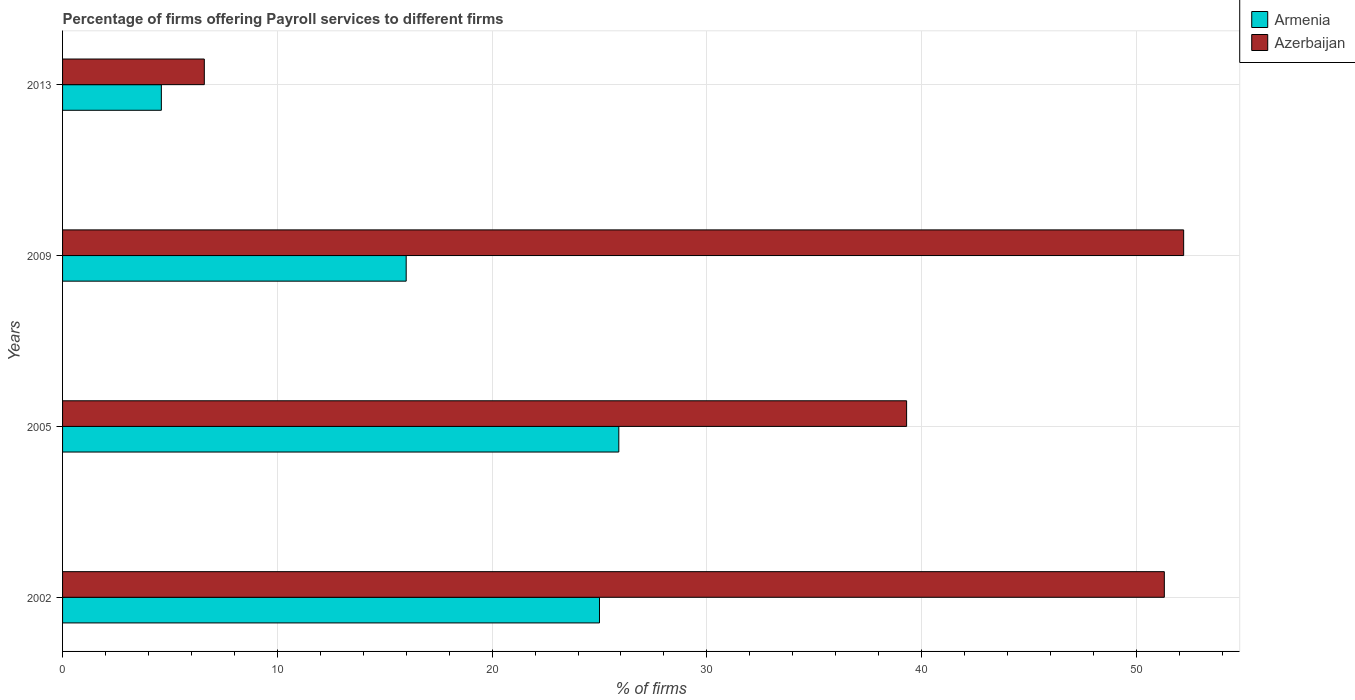How many groups of bars are there?
Your answer should be very brief. 4. Are the number of bars per tick equal to the number of legend labels?
Offer a very short reply. Yes. Are the number of bars on each tick of the Y-axis equal?
Provide a succinct answer. Yes. How many bars are there on the 1st tick from the top?
Keep it short and to the point. 2. How many bars are there on the 2nd tick from the bottom?
Make the answer very short. 2. What is the percentage of firms offering payroll services in Azerbaijan in 2002?
Offer a very short reply. 51.3. Across all years, what is the maximum percentage of firms offering payroll services in Armenia?
Your answer should be very brief. 25.9. In which year was the percentage of firms offering payroll services in Armenia maximum?
Your answer should be compact. 2005. What is the total percentage of firms offering payroll services in Armenia in the graph?
Your answer should be very brief. 71.5. What is the difference between the percentage of firms offering payroll services in Azerbaijan in 2002 and that in 2009?
Your response must be concise. -0.9. What is the difference between the percentage of firms offering payroll services in Armenia in 2005 and the percentage of firms offering payroll services in Azerbaijan in 2002?
Give a very brief answer. -25.4. What is the average percentage of firms offering payroll services in Armenia per year?
Keep it short and to the point. 17.88. In the year 2005, what is the difference between the percentage of firms offering payroll services in Armenia and percentage of firms offering payroll services in Azerbaijan?
Keep it short and to the point. -13.4. In how many years, is the percentage of firms offering payroll services in Armenia greater than 16 %?
Provide a short and direct response. 2. What is the ratio of the percentage of firms offering payroll services in Azerbaijan in 2002 to that in 2013?
Offer a terse response. 7.77. Is the difference between the percentage of firms offering payroll services in Armenia in 2005 and 2013 greater than the difference between the percentage of firms offering payroll services in Azerbaijan in 2005 and 2013?
Your response must be concise. No. What is the difference between the highest and the second highest percentage of firms offering payroll services in Azerbaijan?
Keep it short and to the point. 0.9. What is the difference between the highest and the lowest percentage of firms offering payroll services in Armenia?
Offer a terse response. 21.3. What does the 2nd bar from the top in 2005 represents?
Offer a very short reply. Armenia. What does the 1st bar from the bottom in 2013 represents?
Offer a terse response. Armenia. How many bars are there?
Ensure brevity in your answer.  8. How many years are there in the graph?
Make the answer very short. 4. What is the difference between two consecutive major ticks on the X-axis?
Offer a very short reply. 10. Are the values on the major ticks of X-axis written in scientific E-notation?
Keep it short and to the point. No. What is the title of the graph?
Keep it short and to the point. Percentage of firms offering Payroll services to different firms. Does "Austria" appear as one of the legend labels in the graph?
Keep it short and to the point. No. What is the label or title of the X-axis?
Your answer should be very brief. % of firms. What is the % of firms of Azerbaijan in 2002?
Ensure brevity in your answer.  51.3. What is the % of firms in Armenia in 2005?
Your answer should be very brief. 25.9. What is the % of firms of Azerbaijan in 2005?
Your answer should be compact. 39.3. What is the % of firms in Azerbaijan in 2009?
Your response must be concise. 52.2. What is the % of firms in Azerbaijan in 2013?
Your answer should be compact. 6.6. Across all years, what is the maximum % of firms of Armenia?
Your response must be concise. 25.9. Across all years, what is the maximum % of firms of Azerbaijan?
Your answer should be very brief. 52.2. What is the total % of firms of Armenia in the graph?
Provide a succinct answer. 71.5. What is the total % of firms in Azerbaijan in the graph?
Make the answer very short. 149.4. What is the difference between the % of firms of Azerbaijan in 2002 and that in 2005?
Ensure brevity in your answer.  12. What is the difference between the % of firms in Armenia in 2002 and that in 2013?
Your answer should be compact. 20.4. What is the difference between the % of firms in Azerbaijan in 2002 and that in 2013?
Give a very brief answer. 44.7. What is the difference between the % of firms of Armenia in 2005 and that in 2009?
Provide a succinct answer. 9.9. What is the difference between the % of firms in Armenia in 2005 and that in 2013?
Offer a very short reply. 21.3. What is the difference between the % of firms of Azerbaijan in 2005 and that in 2013?
Ensure brevity in your answer.  32.7. What is the difference between the % of firms of Azerbaijan in 2009 and that in 2013?
Make the answer very short. 45.6. What is the difference between the % of firms of Armenia in 2002 and the % of firms of Azerbaijan in 2005?
Keep it short and to the point. -14.3. What is the difference between the % of firms in Armenia in 2002 and the % of firms in Azerbaijan in 2009?
Keep it short and to the point. -27.2. What is the difference between the % of firms of Armenia in 2002 and the % of firms of Azerbaijan in 2013?
Provide a succinct answer. 18.4. What is the difference between the % of firms in Armenia in 2005 and the % of firms in Azerbaijan in 2009?
Ensure brevity in your answer.  -26.3. What is the difference between the % of firms of Armenia in 2005 and the % of firms of Azerbaijan in 2013?
Give a very brief answer. 19.3. What is the difference between the % of firms of Armenia in 2009 and the % of firms of Azerbaijan in 2013?
Provide a succinct answer. 9.4. What is the average % of firms in Armenia per year?
Your response must be concise. 17.88. What is the average % of firms in Azerbaijan per year?
Provide a succinct answer. 37.35. In the year 2002, what is the difference between the % of firms of Armenia and % of firms of Azerbaijan?
Provide a short and direct response. -26.3. In the year 2005, what is the difference between the % of firms in Armenia and % of firms in Azerbaijan?
Your answer should be compact. -13.4. In the year 2009, what is the difference between the % of firms in Armenia and % of firms in Azerbaijan?
Your response must be concise. -36.2. What is the ratio of the % of firms of Armenia in 2002 to that in 2005?
Your answer should be very brief. 0.97. What is the ratio of the % of firms in Azerbaijan in 2002 to that in 2005?
Your response must be concise. 1.31. What is the ratio of the % of firms of Armenia in 2002 to that in 2009?
Your answer should be compact. 1.56. What is the ratio of the % of firms in Azerbaijan in 2002 to that in 2009?
Offer a terse response. 0.98. What is the ratio of the % of firms in Armenia in 2002 to that in 2013?
Ensure brevity in your answer.  5.43. What is the ratio of the % of firms of Azerbaijan in 2002 to that in 2013?
Your response must be concise. 7.77. What is the ratio of the % of firms in Armenia in 2005 to that in 2009?
Your response must be concise. 1.62. What is the ratio of the % of firms in Azerbaijan in 2005 to that in 2009?
Your answer should be compact. 0.75. What is the ratio of the % of firms of Armenia in 2005 to that in 2013?
Offer a very short reply. 5.63. What is the ratio of the % of firms of Azerbaijan in 2005 to that in 2013?
Your answer should be compact. 5.95. What is the ratio of the % of firms of Armenia in 2009 to that in 2013?
Offer a terse response. 3.48. What is the ratio of the % of firms of Azerbaijan in 2009 to that in 2013?
Your answer should be compact. 7.91. What is the difference between the highest and the lowest % of firms in Armenia?
Your answer should be compact. 21.3. What is the difference between the highest and the lowest % of firms in Azerbaijan?
Offer a very short reply. 45.6. 